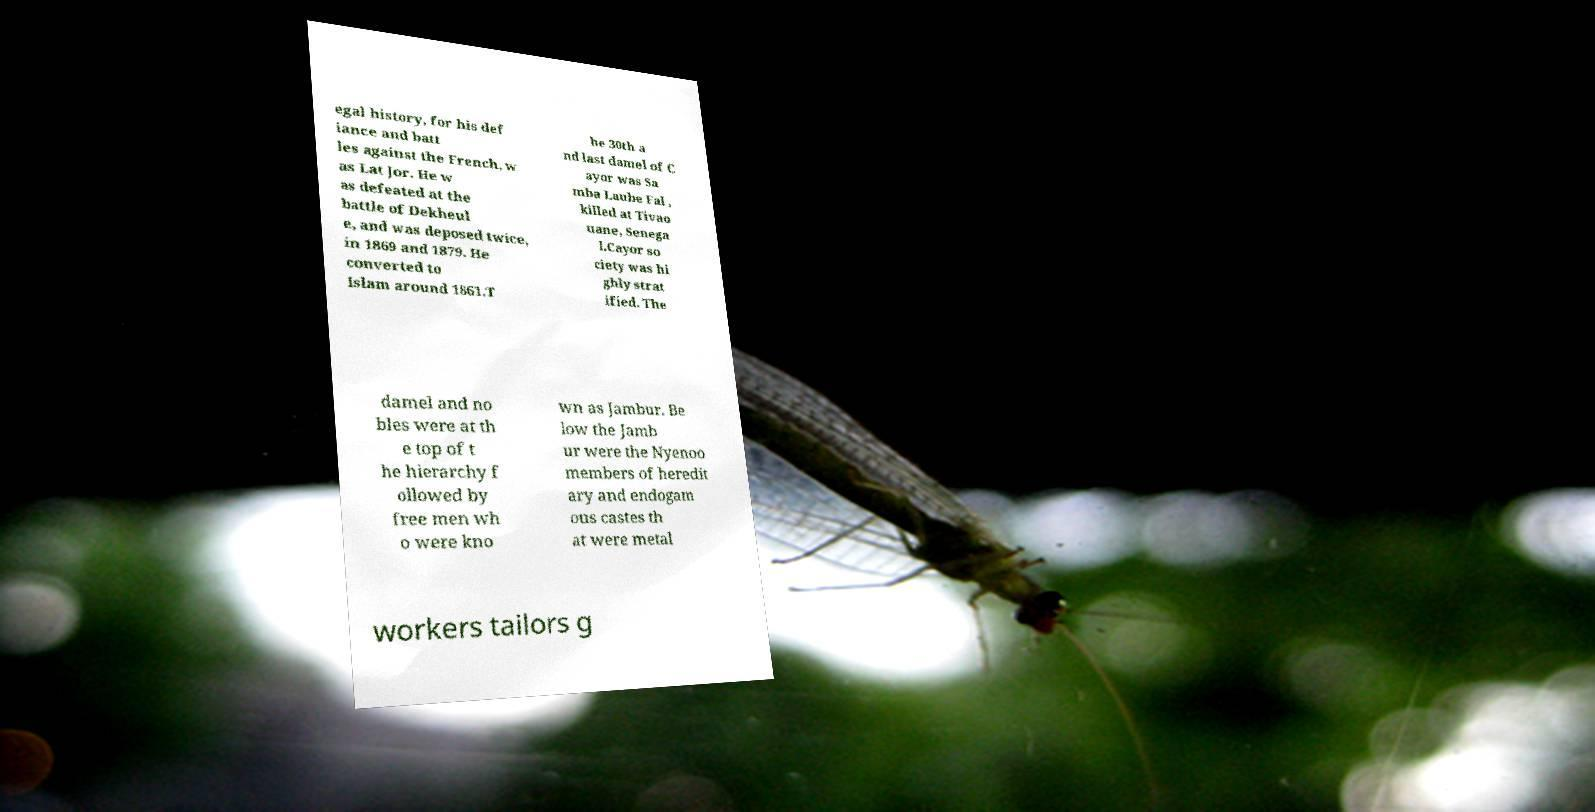I need the written content from this picture converted into text. Can you do that? egal history, for his def iance and batt les against the French, w as Lat Jor. He w as defeated at the battle of Dekheul e, and was deposed twice, in 1869 and 1879. He converted to Islam around 1861.T he 30th a nd last damel of C ayor was Sa mba Laube Fal , killed at Tivao uane, Senega l.Cayor so ciety was hi ghly strat ified. The damel and no bles were at th e top of t he hierarchy f ollowed by free men wh o were kno wn as Jambur. Be low the Jamb ur were the Nyenoo members of heredit ary and endogam ous castes th at were metal workers tailors g 